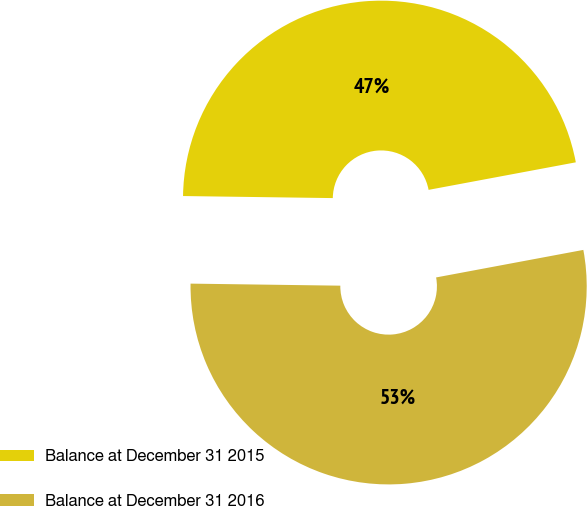Convert chart. <chart><loc_0><loc_0><loc_500><loc_500><pie_chart><fcel>Balance at December 31 2015<fcel>Balance at December 31 2016<nl><fcel>46.84%<fcel>53.16%<nl></chart> 